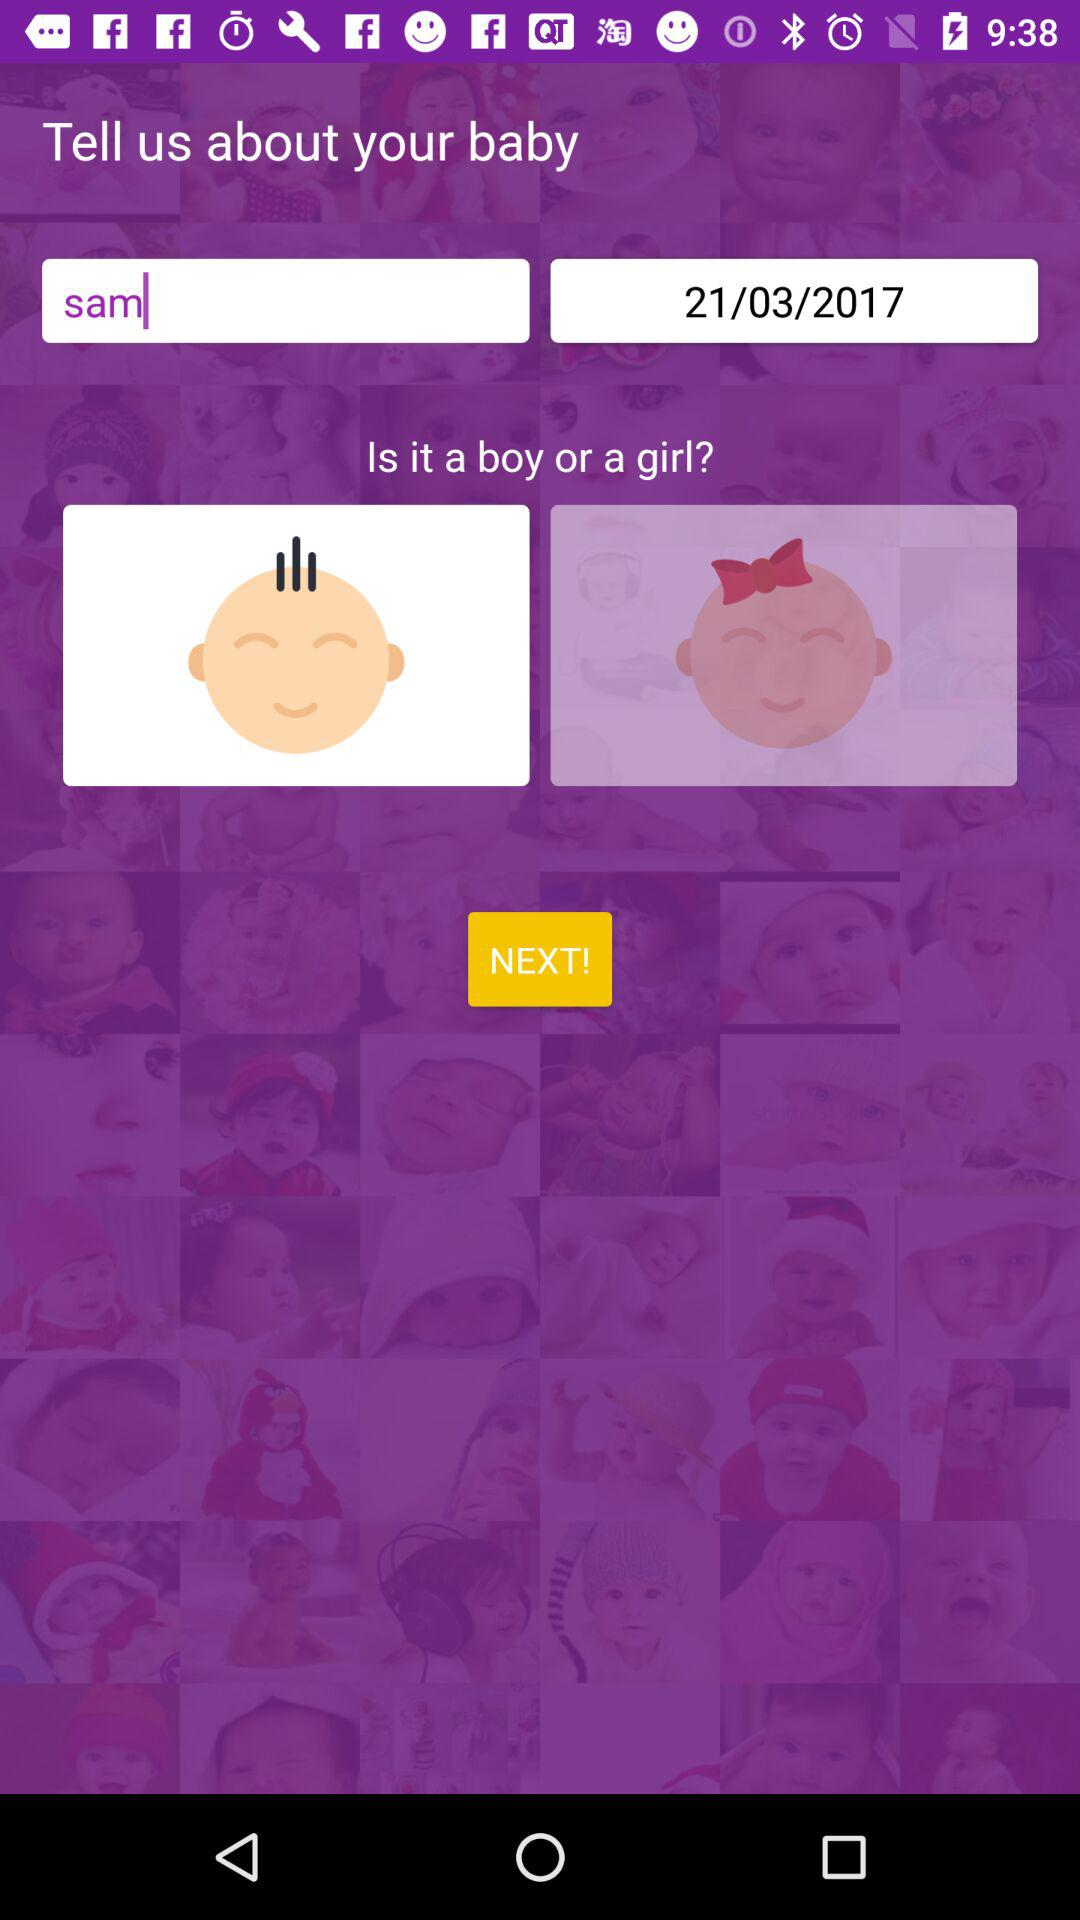What is the name? The name is Sam. 